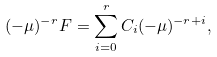Convert formula to latex. <formula><loc_0><loc_0><loc_500><loc_500>( - \mu ) ^ { - r } F = \sum _ { i = 0 } ^ { r } C _ { i } ( - \mu ) ^ { - r + i } ,</formula> 